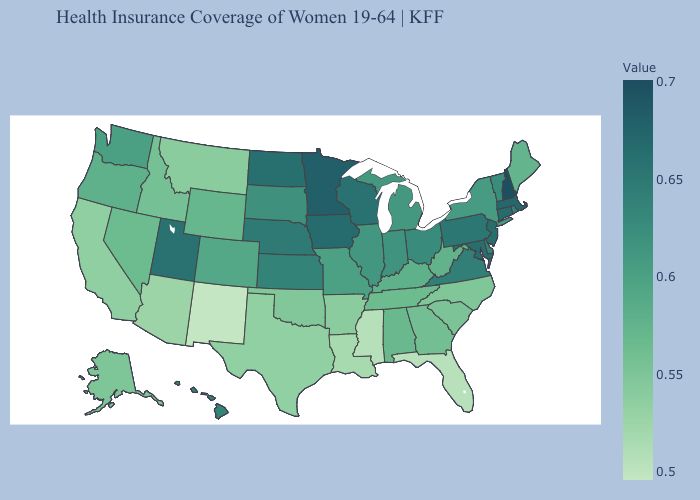Which states have the lowest value in the Northeast?
Short answer required. Maine. Does Virginia have a lower value than New Jersey?
Answer briefly. Yes. Is the legend a continuous bar?
Be succinct. Yes. Among the states that border Connecticut , which have the lowest value?
Write a very short answer. New York. Does New Hampshire have the highest value in the USA?
Be succinct. Yes. Does Maine have the lowest value in the USA?
Concise answer only. No. 